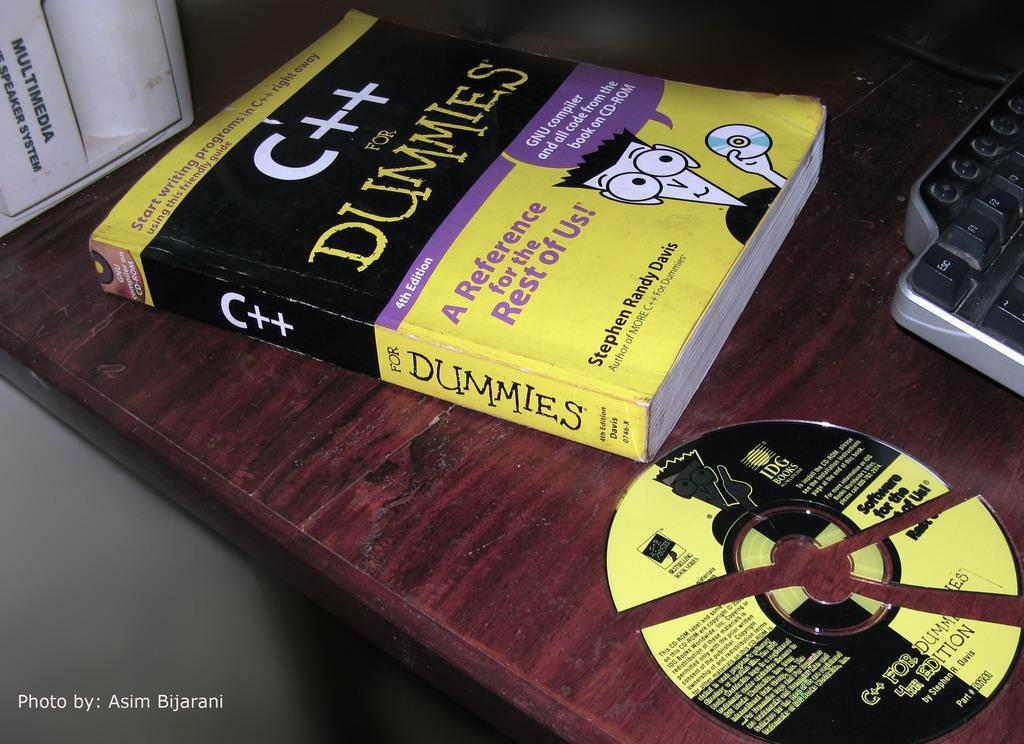<image>
Render a clear and concise summary of the photo. The book C++ for Dummies sits next to a Cd-Rom on the same topic 